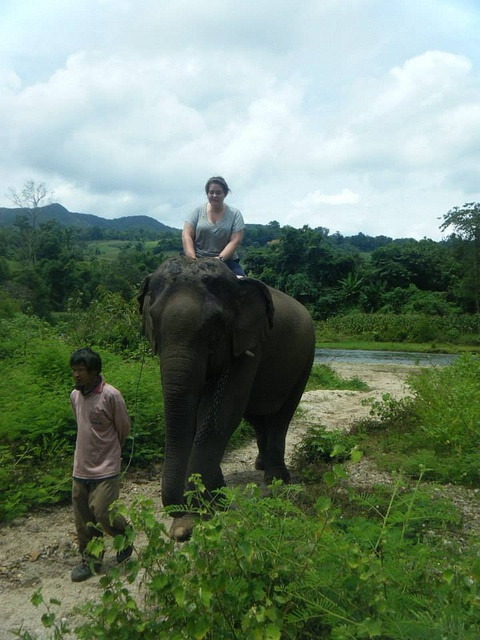Describe the objects in this image and their specific colors. I can see elephant in lightblue, black, gray, and darkgreen tones, people in lightblue, black, gray, and darkgreen tones, and people in lightblue, gray, darkgray, purple, and black tones in this image. 